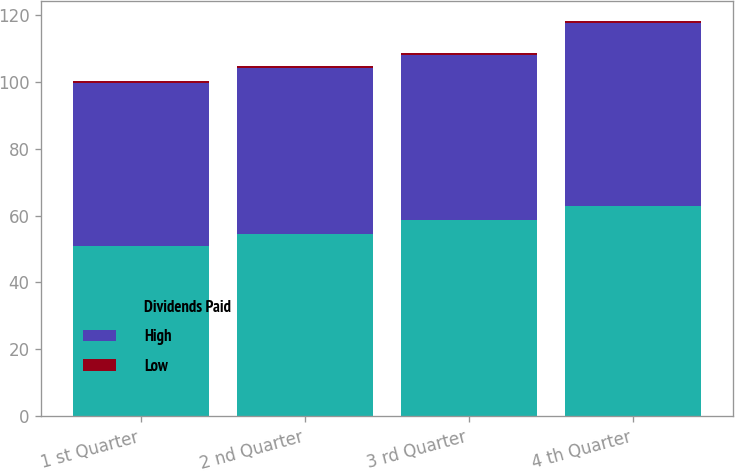Convert chart. <chart><loc_0><loc_0><loc_500><loc_500><stacked_bar_chart><ecel><fcel>1 st Quarter<fcel>2 nd Quarter<fcel>3 rd Quarter<fcel>4 th Quarter<nl><fcel>Dividends Paid<fcel>50.9<fcel>54.36<fcel>58.79<fcel>62.74<nl><fcel>High<fcel>48.55<fcel>49.8<fcel>49.18<fcel>54.72<nl><fcel>Low<fcel>0.6<fcel>0.6<fcel>0.6<fcel>0.6<nl></chart> 